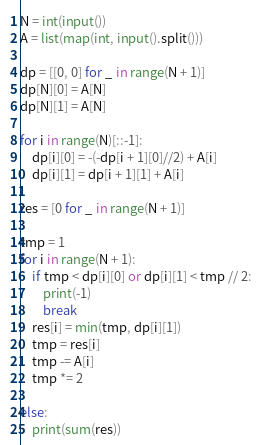Convert code to text. <code><loc_0><loc_0><loc_500><loc_500><_Python_>N = int(input())
A = list(map(int, input().split()))

dp = [[0, 0] for _ in range(N + 1)]
dp[N][0] = A[N]
dp[N][1] = A[N]

for i in range(N)[::-1]:
    dp[i][0] = -(-dp[i + 1][0]//2) + A[i]
    dp[i][1] = dp[i + 1][1] + A[i]

res = [0 for _ in range(N + 1)]

tmp = 1
for i in range(N + 1):
    if tmp < dp[i][0] or dp[i][1] < tmp // 2:
        print(-1)
        break
    res[i] = min(tmp, dp[i][1])
    tmp = res[i]
    tmp -= A[i]
    tmp *= 2

else:
    print(sum(res))</code> 